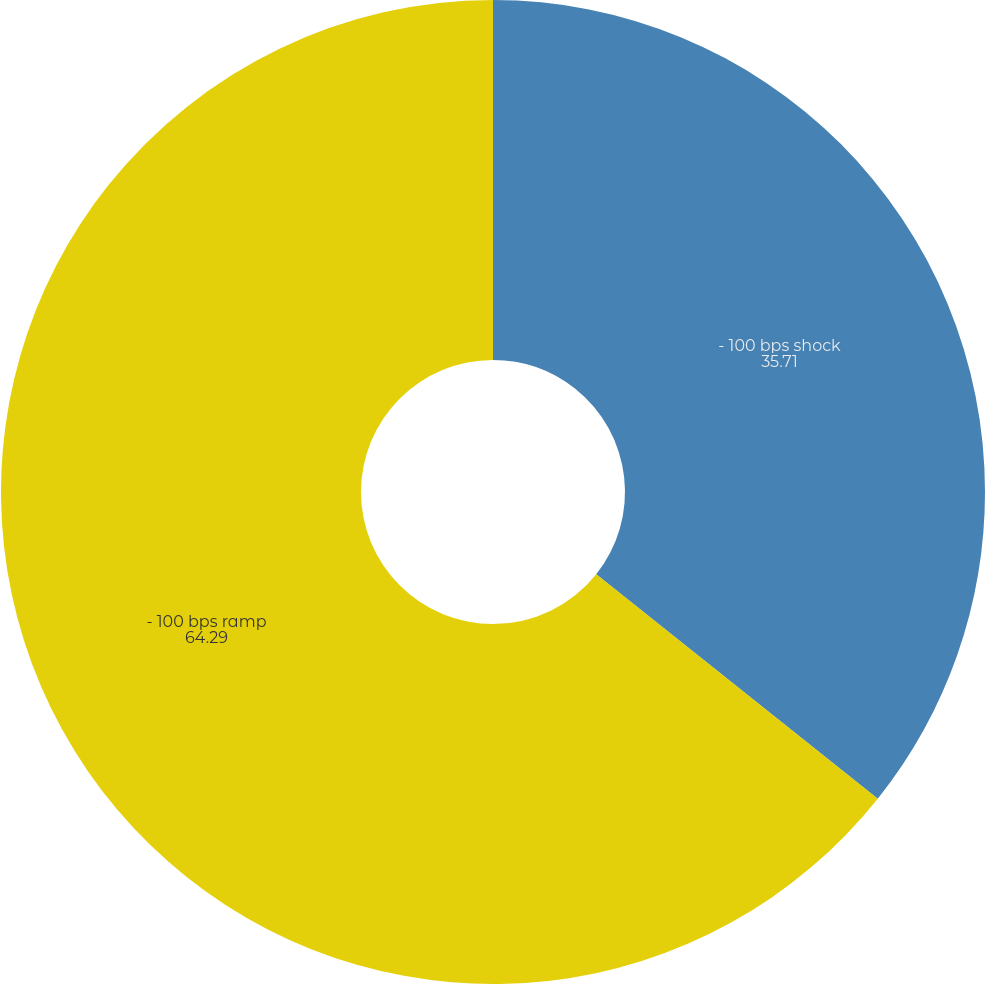<chart> <loc_0><loc_0><loc_500><loc_500><pie_chart><fcel>- 100 bps shock<fcel>- 100 bps ramp<nl><fcel>35.71%<fcel>64.29%<nl></chart> 